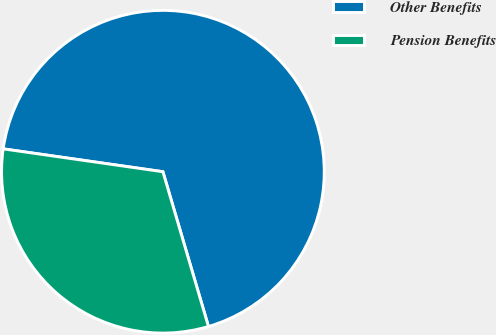<chart> <loc_0><loc_0><loc_500><loc_500><pie_chart><fcel>Other Benefits<fcel>Pension Benefits<nl><fcel>68.18%<fcel>31.82%<nl></chart> 